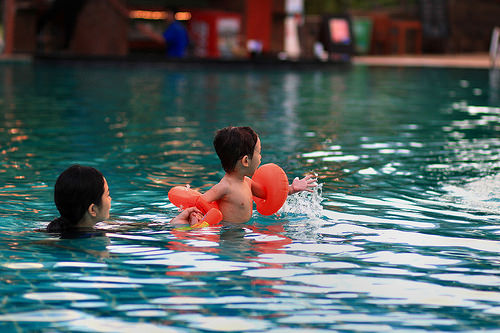<image>
Can you confirm if the water is under the girl? No. The water is not positioned under the girl. The vertical relationship between these objects is different. Is the little boy in the water? Yes. The little boy is contained within or inside the water, showing a containment relationship. 